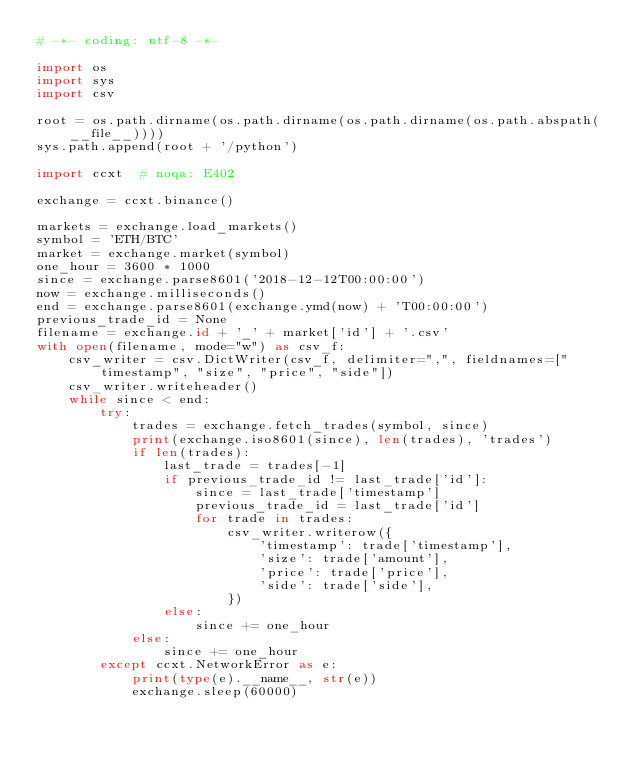Convert code to text. <code><loc_0><loc_0><loc_500><loc_500><_Python_># -*- coding: utf-8 -*-

import os
import sys
import csv

root = os.path.dirname(os.path.dirname(os.path.dirname(os.path.abspath(__file__))))
sys.path.append(root + '/python')

import ccxt  # noqa: E402

exchange = ccxt.binance()

markets = exchange.load_markets()
symbol = 'ETH/BTC'
market = exchange.market(symbol)
one_hour = 3600 * 1000
since = exchange.parse8601('2018-12-12T00:00:00')
now = exchange.milliseconds()
end = exchange.parse8601(exchange.ymd(now) + 'T00:00:00')
previous_trade_id = None
filename = exchange.id + '_' + market['id'] + '.csv'
with open(filename, mode="w") as csv_f:
    csv_writer = csv.DictWriter(csv_f, delimiter=",", fieldnames=["timestamp", "size", "price", "side"])
    csv_writer.writeheader()
    while since < end:
        try:
            trades = exchange.fetch_trades(symbol, since)
            print(exchange.iso8601(since), len(trades), 'trades')
            if len(trades):
                last_trade = trades[-1]
                if previous_trade_id != last_trade['id']:
                    since = last_trade['timestamp']
                    previous_trade_id = last_trade['id']
                    for trade in trades:
                        csv_writer.writerow({
                            'timestamp': trade['timestamp'],
                            'size': trade['amount'],
                            'price': trade['price'],
                            'side': trade['side'],
                        })
                else:
                    since += one_hour
            else:
                since += one_hour
        except ccxt.NetworkError as e:
            print(type(e).__name__, str(e))
            exchange.sleep(60000)
</code> 